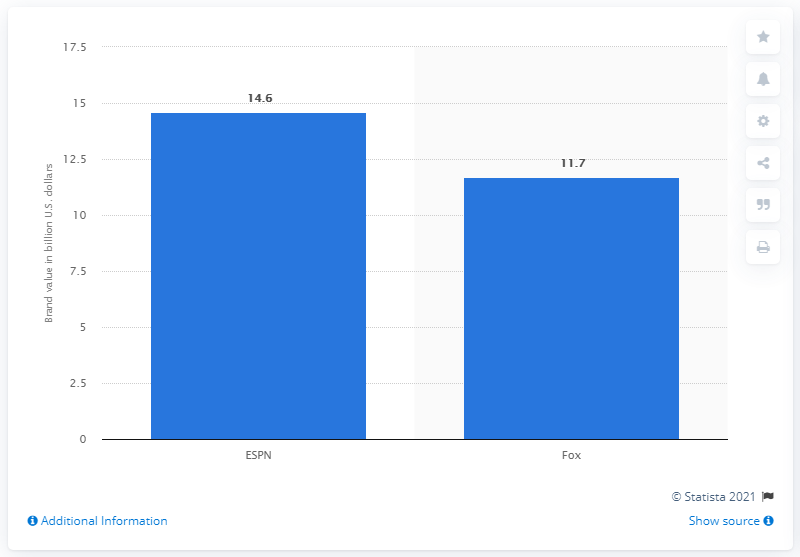Mention a couple of crucial points in this snapshot. In 2018, ESPN was the most valuable media brand. 